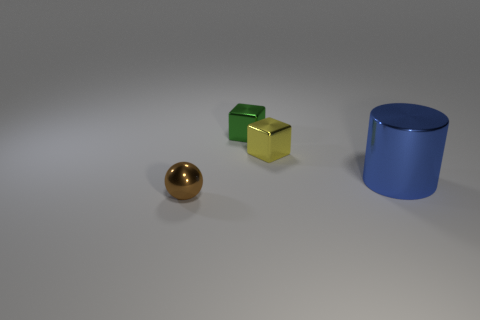Add 1 tiny blocks. How many objects exist? 5 Subtract all spheres. How many objects are left? 3 Add 4 green shiny blocks. How many green shiny blocks exist? 5 Subtract 1 brown balls. How many objects are left? 3 Subtract all cyan matte spheres. Subtract all small metallic objects. How many objects are left? 1 Add 3 tiny brown metal balls. How many tiny brown metal balls are left? 4 